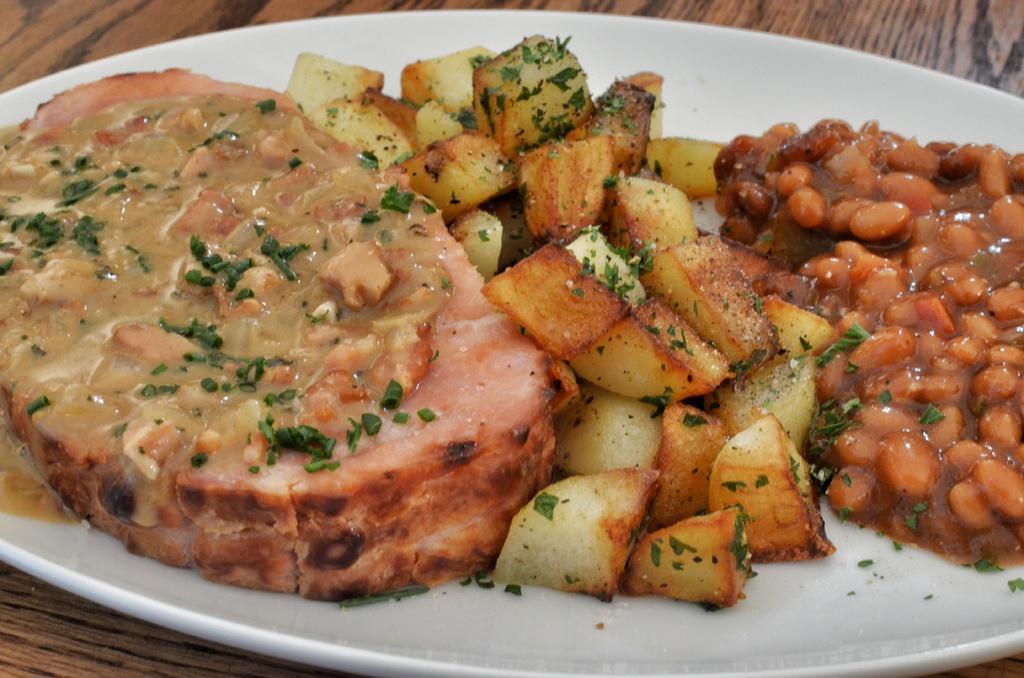Could you give a brief overview of what you see in this image? This is a zoomed in picture. In the center there is a white color palette containing some food items. In the background there is a brown color object seems to be a table. 